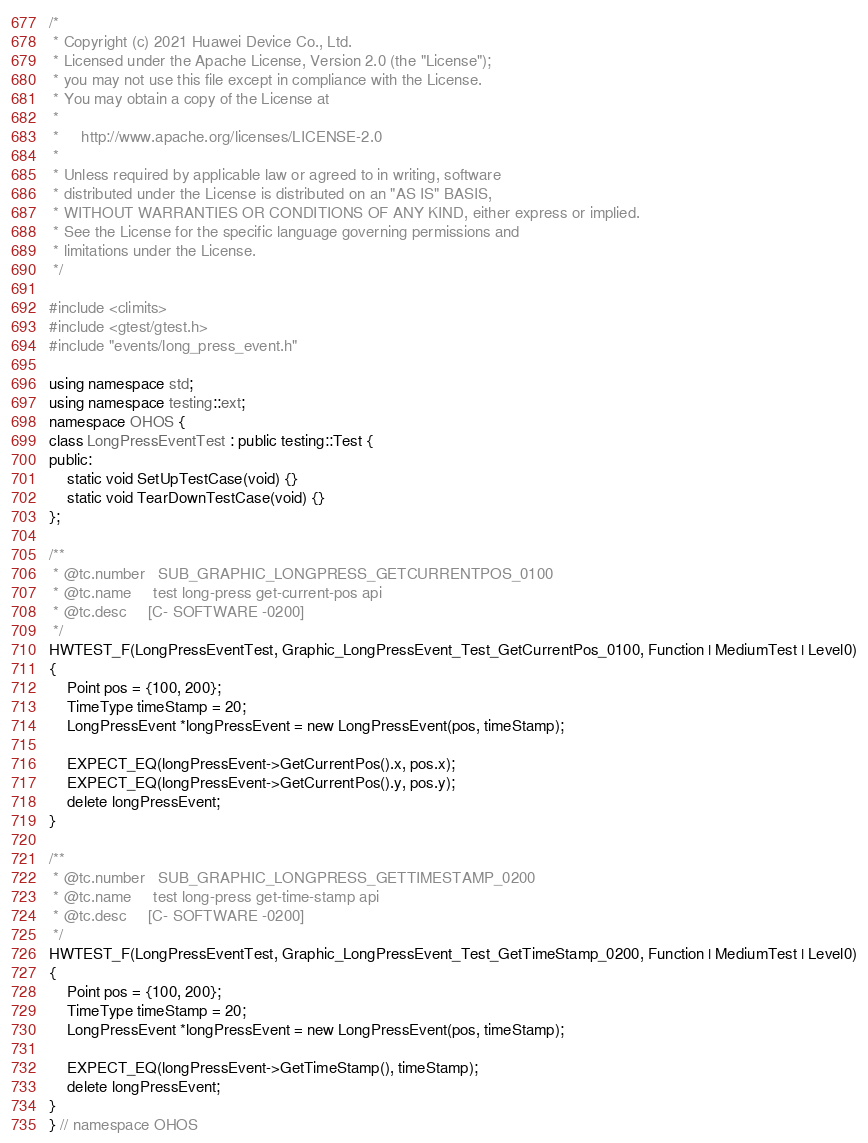Convert code to text. <code><loc_0><loc_0><loc_500><loc_500><_C++_>/*
 * Copyright (c) 2021 Huawei Device Co., Ltd.
 * Licensed under the Apache License, Version 2.0 (the "License");
 * you may not use this file except in compliance with the License.
 * You may obtain a copy of the License at
 *
 *     http://www.apache.org/licenses/LICENSE-2.0
 *
 * Unless required by applicable law or agreed to in writing, software
 * distributed under the License is distributed on an "AS IS" BASIS,
 * WITHOUT WARRANTIES OR CONDITIONS OF ANY KIND, either express or implied.
 * See the License for the specific language governing permissions and
 * limitations under the License.
 */

#include <climits>
#include <gtest/gtest.h>
#include "events/long_press_event.h"

using namespace std;
using namespace testing::ext;
namespace OHOS {
class LongPressEventTest : public testing::Test {
public:
    static void SetUpTestCase(void) {}
    static void TearDownTestCase(void) {}
};

/**
 * @tc.number   SUB_GRAPHIC_LONGPRESS_GETCURRENTPOS_0100
 * @tc.name     test long-press get-current-pos api
 * @tc.desc     [C- SOFTWARE -0200]
 */
HWTEST_F(LongPressEventTest, Graphic_LongPressEvent_Test_GetCurrentPos_0100, Function | MediumTest | Level0)
{
    Point pos = {100, 200};
    TimeType timeStamp = 20;
    LongPressEvent *longPressEvent = new LongPressEvent(pos, timeStamp);

    EXPECT_EQ(longPressEvent->GetCurrentPos().x, pos.x);
    EXPECT_EQ(longPressEvent->GetCurrentPos().y, pos.y);
    delete longPressEvent;
}

/**
 * @tc.number   SUB_GRAPHIC_LONGPRESS_GETTIMESTAMP_0200
 * @tc.name     test long-press get-time-stamp api
 * @tc.desc     [C- SOFTWARE -0200]
 */
HWTEST_F(LongPressEventTest, Graphic_LongPressEvent_Test_GetTimeStamp_0200, Function | MediumTest | Level0)
{
    Point pos = {100, 200};
    TimeType timeStamp = 20;
    LongPressEvent *longPressEvent = new LongPressEvent(pos, timeStamp);

    EXPECT_EQ(longPressEvent->GetTimeStamp(), timeStamp);
    delete longPressEvent;
}
} // namespace OHOS
</code> 